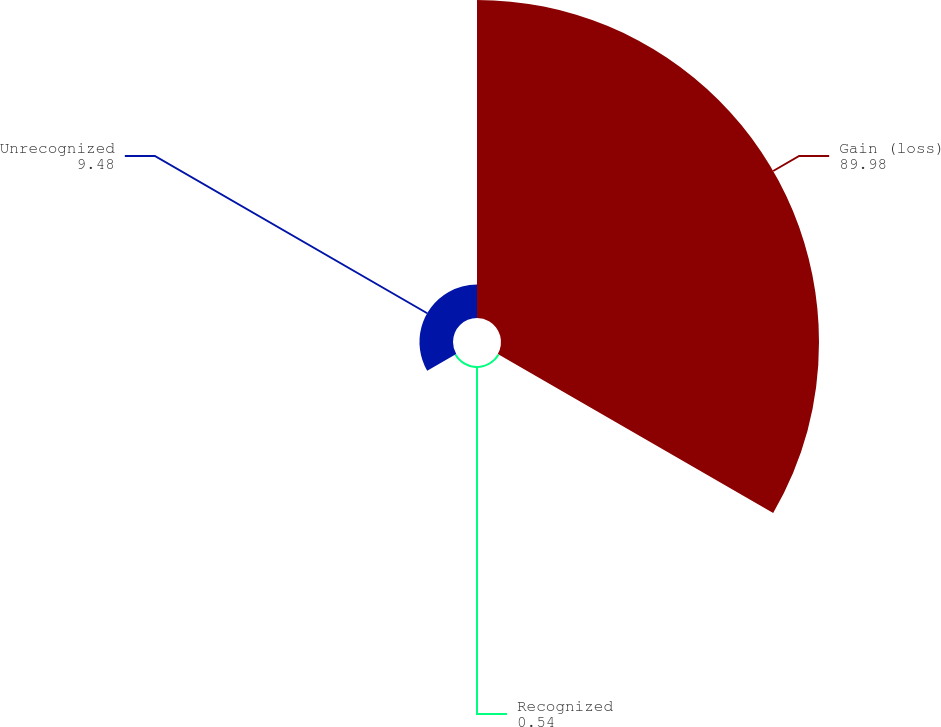Convert chart to OTSL. <chart><loc_0><loc_0><loc_500><loc_500><pie_chart><fcel>Gain (loss)<fcel>Recognized<fcel>Unrecognized<nl><fcel>89.98%<fcel>0.54%<fcel>9.48%<nl></chart> 